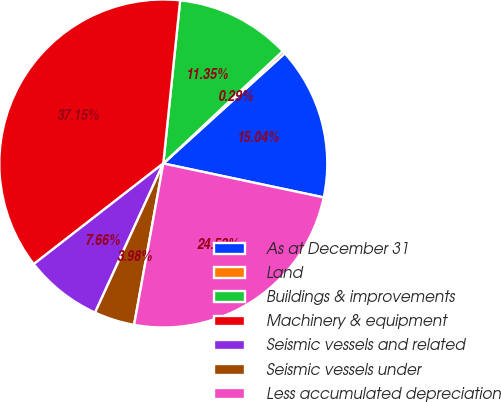Convert chart. <chart><loc_0><loc_0><loc_500><loc_500><pie_chart><fcel>As at December 31<fcel>Land<fcel>Buildings & improvements<fcel>Machinery & equipment<fcel>Seismic vessels and related<fcel>Seismic vessels under<fcel>Less accumulated depreciation<nl><fcel>15.04%<fcel>0.29%<fcel>11.35%<fcel>37.15%<fcel>7.66%<fcel>3.98%<fcel>24.53%<nl></chart> 